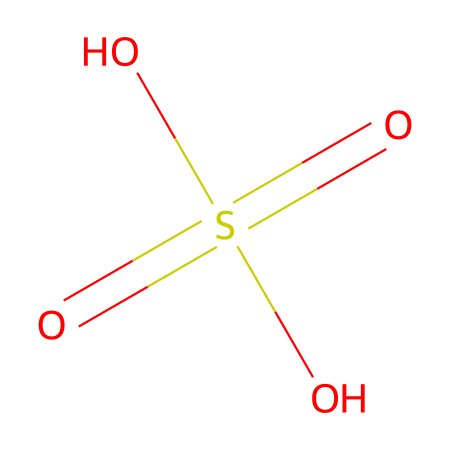How many oxygen atoms are in the molecular structure? The SMILES representation contains four oxygen atoms (two in the sulfonyl group and two in hydroxyl groups).
Answer: four What type of acid is represented by this molecular structure? This structure represents a strong acid known as sulfuric acid. It is classified as a mineral acid due to its strong acidic properties.
Answer: mineral acid What is the central atom in the chemical structure? The central atom in the sulfuric acid structure is sulfur, which is indicated as the main component in the sulfonyl group.
Answer: sulfur How many total hydrogen atoms are present in this structure? In the given structure, there are two hydrogen atoms attached to the two hydroxyl groups, which confirms the total of two hydrogen atoms in sulfuric acid.
Answer: two What property is typically associated with this acid when used in etching? Sulfuric acid is known for its corrosive property, which is essential for effectively etching printing plates by removing materials.
Answer: corrosive How does this structure contribute to the strong acidic nature? The presence of the sulfur atom bonded to four oxygen atoms creates a highly stable configuration that facilitates the dissociation of hydrogen ions, contributing to its strong acidity.
Answer: dissociation of hydrogen ions 